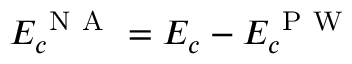<formula> <loc_0><loc_0><loc_500><loc_500>E _ { c } ^ { N A } = E _ { c } - E _ { c } ^ { P W }</formula> 